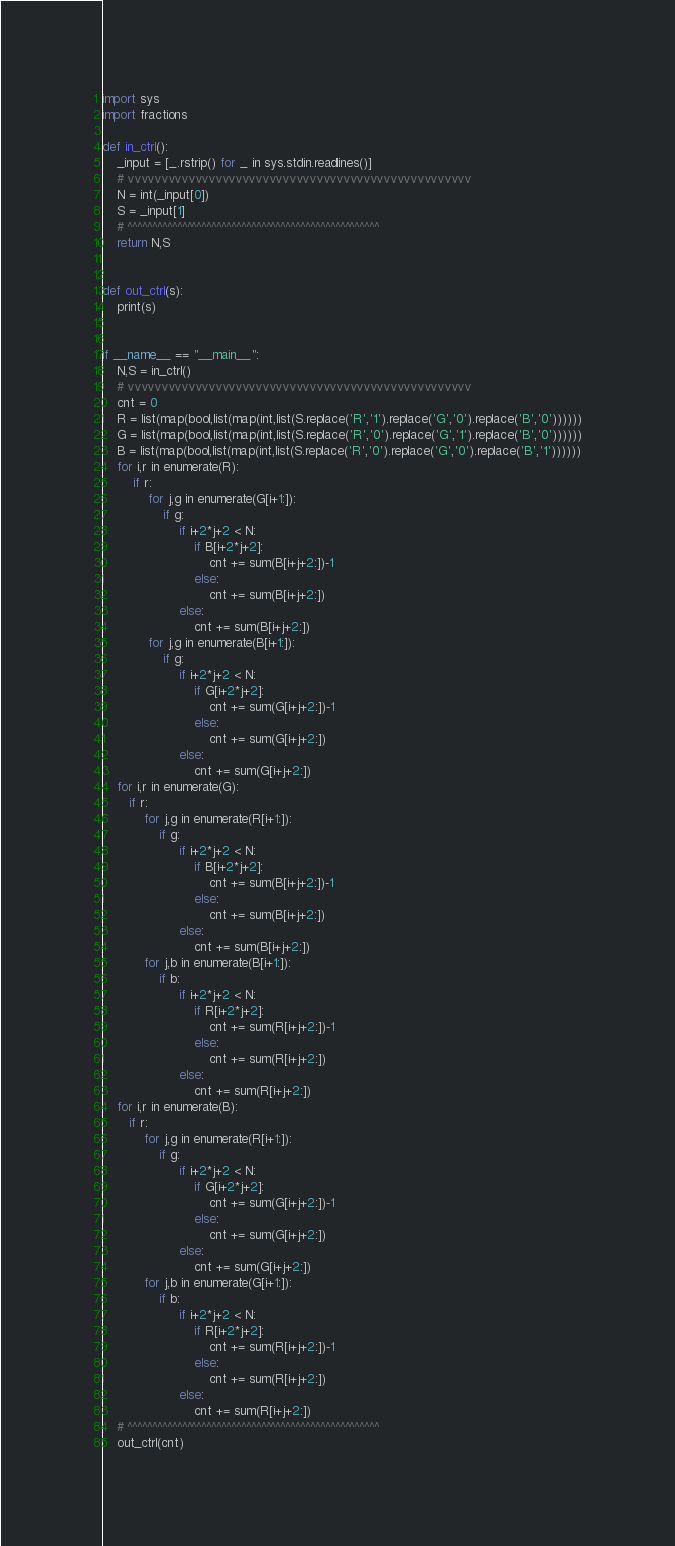<code> <loc_0><loc_0><loc_500><loc_500><_Python_>import sys
import fractions

def in_ctrl():
    _input = [_.rstrip() for _ in sys.stdin.readlines()]
    # vvvvvvvvvvvvvvvvvvvvvvvvvvvvvvvvvvvvvvvvvvvvvvvvvvv
    N = int(_input[0])
    S = _input[1]
    # ^^^^^^^^^^^^^^^^^^^^^^^^^^^^^^^^^^^^^^^^^^^^^^^^^^^
    return N,S


def out_ctrl(s):
    print(s)


if __name__ == "__main__":
    N,S = in_ctrl()
    # vvvvvvvvvvvvvvvvvvvvvvvvvvvvvvvvvvvvvvvvvvvvvvvvvvv
    cnt = 0
    R = list(map(bool,list(map(int,list(S.replace('R','1').replace('G','0').replace('B','0'))))))
    G = list(map(bool,list(map(int,list(S.replace('R','0').replace('G','1').replace('B','0'))))))
    B = list(map(bool,list(map(int,list(S.replace('R','0').replace('G','0').replace('B','1'))))))
    for i,r in enumerate(R):
        if r:
            for j,g in enumerate(G[i+1:]):
                if g:
                    if i+2*j+2 < N:
                        if B[i+2*j+2]:
                            cnt += sum(B[i+j+2:])-1
                        else:
                            cnt += sum(B[i+j+2:])
                    else:
                        cnt += sum(B[i+j+2:])
            for j,g in enumerate(B[i+1:]):
                if g:
                    if i+2*j+2 < N:
                        if G[i+2*j+2]:
                            cnt += sum(G[i+j+2:])-1
                        else:
                            cnt += sum(G[i+j+2:])
                    else:
                        cnt += sum(G[i+j+2:])
    for i,r in enumerate(G):
       if r:
           for j,g in enumerate(R[i+1:]):
               if g:
                    if i+2*j+2 < N:
                        if B[i+2*j+2]:
                            cnt += sum(B[i+j+2:])-1
                        else:
                            cnt += sum(B[i+j+2:])
                    else:
                        cnt += sum(B[i+j+2:])
           for j,b in enumerate(B[i+1:]):
               if b:
                    if i+2*j+2 < N:
                        if R[i+2*j+2]:
                            cnt += sum(R[i+j+2:])-1
                        else:
                            cnt += sum(R[i+j+2:])
                    else:
                        cnt += sum(R[i+j+2:])
    for i,r in enumerate(B):
       if r:
           for j,g in enumerate(R[i+1:]):
               if g:
                    if i+2*j+2 < N:
                        if G[i+2*j+2]:
                            cnt += sum(G[i+j+2:])-1
                        else:
                            cnt += sum(G[i+j+2:])
                    else:
                        cnt += sum(G[i+j+2:])
           for j,b in enumerate(G[i+1:]):
               if b:
                    if i+2*j+2 < N:
                        if R[i+2*j+2]:
                            cnt += sum(R[i+j+2:])-1
                        else:
                            cnt += sum(R[i+j+2:])
                    else:
                        cnt += sum(R[i+j+2:])
    # ^^^^^^^^^^^^^^^^^^^^^^^^^^^^^^^^^^^^^^^^^^^^^^^^^^^
    out_ctrl(cnt)</code> 